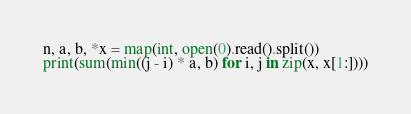Convert code to text. <code><loc_0><loc_0><loc_500><loc_500><_Python_>n, a, b, *x = map(int, open(0).read().split())
print(sum(min((j - i) * a, b) for i, j in zip(x, x[1:])))</code> 